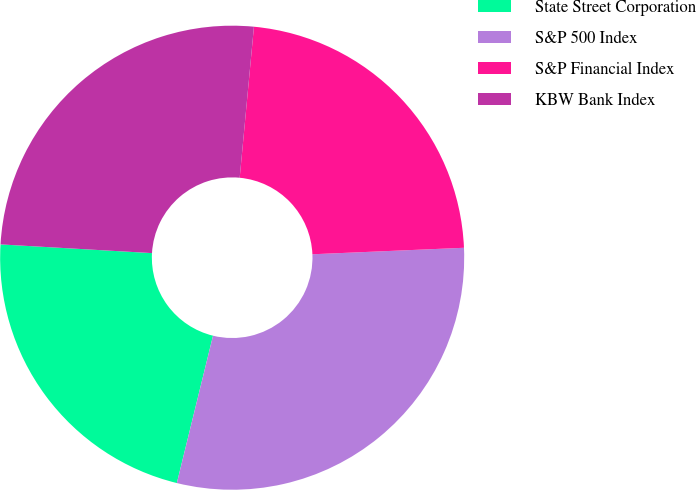<chart> <loc_0><loc_0><loc_500><loc_500><pie_chart><fcel>State Street Corporation<fcel>S&P 500 Index<fcel>S&P Financial Index<fcel>KBW Bank Index<nl><fcel>22.08%<fcel>29.51%<fcel>22.82%<fcel>25.58%<nl></chart> 